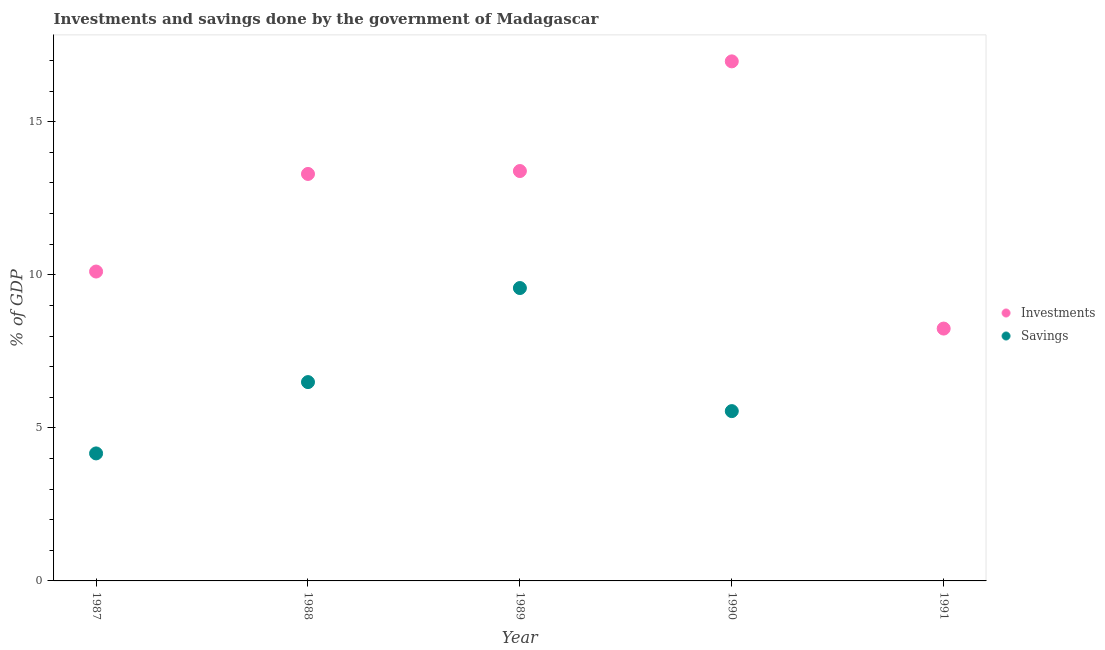What is the investments of government in 1989?
Offer a terse response. 13.39. Across all years, what is the maximum savings of government?
Provide a short and direct response. 9.57. Across all years, what is the minimum investments of government?
Your answer should be very brief. 8.24. In which year was the investments of government maximum?
Provide a succinct answer. 1990. What is the total savings of government in the graph?
Your answer should be compact. 25.77. What is the difference between the investments of government in 1988 and that in 1991?
Give a very brief answer. 5.05. What is the difference between the savings of government in 1987 and the investments of government in 1990?
Your answer should be compact. -12.81. What is the average investments of government per year?
Your answer should be compact. 12.4. In the year 1987, what is the difference between the savings of government and investments of government?
Make the answer very short. -5.94. What is the ratio of the investments of government in 1987 to that in 1989?
Keep it short and to the point. 0.75. What is the difference between the highest and the second highest savings of government?
Give a very brief answer. 3.07. What is the difference between the highest and the lowest investments of government?
Keep it short and to the point. 8.73. In how many years, is the savings of government greater than the average savings of government taken over all years?
Offer a very short reply. 3. Is the sum of the investments of government in 1988 and 1990 greater than the maximum savings of government across all years?
Give a very brief answer. Yes. How many dotlines are there?
Keep it short and to the point. 2. How many years are there in the graph?
Offer a terse response. 5. What is the difference between two consecutive major ticks on the Y-axis?
Make the answer very short. 5. Does the graph contain grids?
Provide a short and direct response. No. How many legend labels are there?
Offer a very short reply. 2. What is the title of the graph?
Your answer should be compact. Investments and savings done by the government of Madagascar. What is the label or title of the X-axis?
Provide a short and direct response. Year. What is the label or title of the Y-axis?
Ensure brevity in your answer.  % of GDP. What is the % of GDP in Investments in 1987?
Offer a very short reply. 10.11. What is the % of GDP of Savings in 1987?
Provide a short and direct response. 4.17. What is the % of GDP in Investments in 1988?
Keep it short and to the point. 13.29. What is the % of GDP in Savings in 1988?
Give a very brief answer. 6.49. What is the % of GDP of Investments in 1989?
Provide a short and direct response. 13.39. What is the % of GDP in Savings in 1989?
Keep it short and to the point. 9.57. What is the % of GDP in Investments in 1990?
Your response must be concise. 16.97. What is the % of GDP in Savings in 1990?
Ensure brevity in your answer.  5.55. What is the % of GDP of Investments in 1991?
Offer a very short reply. 8.24. Across all years, what is the maximum % of GDP in Investments?
Your response must be concise. 16.97. Across all years, what is the maximum % of GDP in Savings?
Keep it short and to the point. 9.57. Across all years, what is the minimum % of GDP in Investments?
Your answer should be compact. 8.24. What is the total % of GDP of Investments in the graph?
Keep it short and to the point. 62.01. What is the total % of GDP in Savings in the graph?
Give a very brief answer. 25.77. What is the difference between the % of GDP in Investments in 1987 and that in 1988?
Offer a terse response. -3.19. What is the difference between the % of GDP of Savings in 1987 and that in 1988?
Provide a short and direct response. -2.33. What is the difference between the % of GDP in Investments in 1987 and that in 1989?
Ensure brevity in your answer.  -3.28. What is the difference between the % of GDP of Savings in 1987 and that in 1989?
Give a very brief answer. -5.4. What is the difference between the % of GDP of Investments in 1987 and that in 1990?
Give a very brief answer. -6.87. What is the difference between the % of GDP of Savings in 1987 and that in 1990?
Offer a very short reply. -1.38. What is the difference between the % of GDP in Investments in 1987 and that in 1991?
Ensure brevity in your answer.  1.86. What is the difference between the % of GDP of Investments in 1988 and that in 1989?
Ensure brevity in your answer.  -0.1. What is the difference between the % of GDP in Savings in 1988 and that in 1989?
Provide a succinct answer. -3.07. What is the difference between the % of GDP of Investments in 1988 and that in 1990?
Provide a succinct answer. -3.68. What is the difference between the % of GDP of Savings in 1988 and that in 1990?
Give a very brief answer. 0.95. What is the difference between the % of GDP in Investments in 1988 and that in 1991?
Provide a succinct answer. 5.05. What is the difference between the % of GDP in Investments in 1989 and that in 1990?
Your answer should be very brief. -3.58. What is the difference between the % of GDP of Savings in 1989 and that in 1990?
Offer a very short reply. 4.02. What is the difference between the % of GDP in Investments in 1989 and that in 1991?
Keep it short and to the point. 5.15. What is the difference between the % of GDP of Investments in 1990 and that in 1991?
Offer a very short reply. 8.73. What is the difference between the % of GDP of Investments in 1987 and the % of GDP of Savings in 1988?
Provide a short and direct response. 3.61. What is the difference between the % of GDP of Investments in 1987 and the % of GDP of Savings in 1989?
Provide a short and direct response. 0.54. What is the difference between the % of GDP in Investments in 1987 and the % of GDP in Savings in 1990?
Your answer should be very brief. 4.56. What is the difference between the % of GDP in Investments in 1988 and the % of GDP in Savings in 1989?
Offer a very short reply. 3.73. What is the difference between the % of GDP in Investments in 1988 and the % of GDP in Savings in 1990?
Your answer should be very brief. 7.75. What is the difference between the % of GDP in Investments in 1989 and the % of GDP in Savings in 1990?
Ensure brevity in your answer.  7.84. What is the average % of GDP of Investments per year?
Your answer should be very brief. 12.4. What is the average % of GDP of Savings per year?
Keep it short and to the point. 5.15. In the year 1987, what is the difference between the % of GDP of Investments and % of GDP of Savings?
Keep it short and to the point. 5.94. In the year 1988, what is the difference between the % of GDP of Investments and % of GDP of Savings?
Offer a very short reply. 6.8. In the year 1989, what is the difference between the % of GDP of Investments and % of GDP of Savings?
Offer a very short reply. 3.82. In the year 1990, what is the difference between the % of GDP in Investments and % of GDP in Savings?
Offer a very short reply. 11.43. What is the ratio of the % of GDP in Investments in 1987 to that in 1988?
Your answer should be very brief. 0.76. What is the ratio of the % of GDP of Savings in 1987 to that in 1988?
Provide a short and direct response. 0.64. What is the ratio of the % of GDP of Investments in 1987 to that in 1989?
Your answer should be compact. 0.75. What is the ratio of the % of GDP in Savings in 1987 to that in 1989?
Offer a terse response. 0.44. What is the ratio of the % of GDP of Investments in 1987 to that in 1990?
Offer a very short reply. 0.6. What is the ratio of the % of GDP in Savings in 1987 to that in 1990?
Provide a short and direct response. 0.75. What is the ratio of the % of GDP in Investments in 1987 to that in 1991?
Offer a terse response. 1.23. What is the ratio of the % of GDP of Investments in 1988 to that in 1989?
Offer a terse response. 0.99. What is the ratio of the % of GDP of Savings in 1988 to that in 1989?
Provide a succinct answer. 0.68. What is the ratio of the % of GDP of Investments in 1988 to that in 1990?
Give a very brief answer. 0.78. What is the ratio of the % of GDP of Savings in 1988 to that in 1990?
Provide a succinct answer. 1.17. What is the ratio of the % of GDP of Investments in 1988 to that in 1991?
Your answer should be compact. 1.61. What is the ratio of the % of GDP in Investments in 1989 to that in 1990?
Your response must be concise. 0.79. What is the ratio of the % of GDP in Savings in 1989 to that in 1990?
Give a very brief answer. 1.72. What is the ratio of the % of GDP in Investments in 1989 to that in 1991?
Provide a succinct answer. 1.62. What is the ratio of the % of GDP in Investments in 1990 to that in 1991?
Offer a terse response. 2.06. What is the difference between the highest and the second highest % of GDP in Investments?
Your answer should be compact. 3.58. What is the difference between the highest and the second highest % of GDP in Savings?
Your answer should be very brief. 3.07. What is the difference between the highest and the lowest % of GDP in Investments?
Your answer should be very brief. 8.73. What is the difference between the highest and the lowest % of GDP in Savings?
Provide a succinct answer. 9.57. 